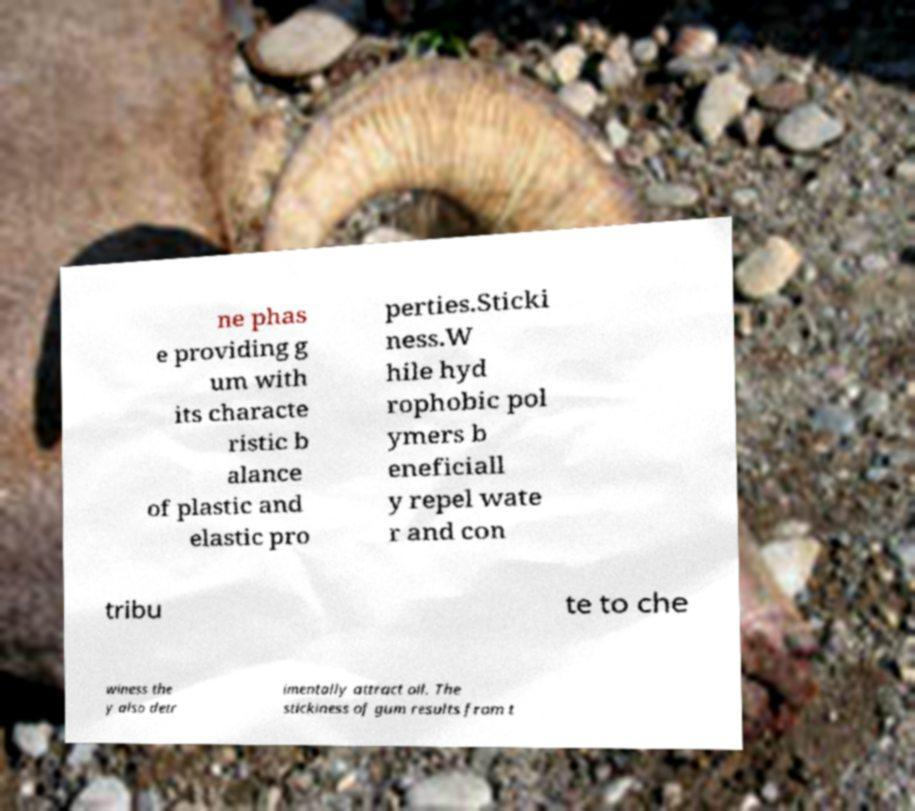Could you extract and type out the text from this image? ne phas e providing g um with its characte ristic b alance of plastic and elastic pro perties.Sticki ness.W hile hyd rophobic pol ymers b eneficiall y repel wate r and con tribu te to che winess the y also detr imentally attract oil. The stickiness of gum results from t 